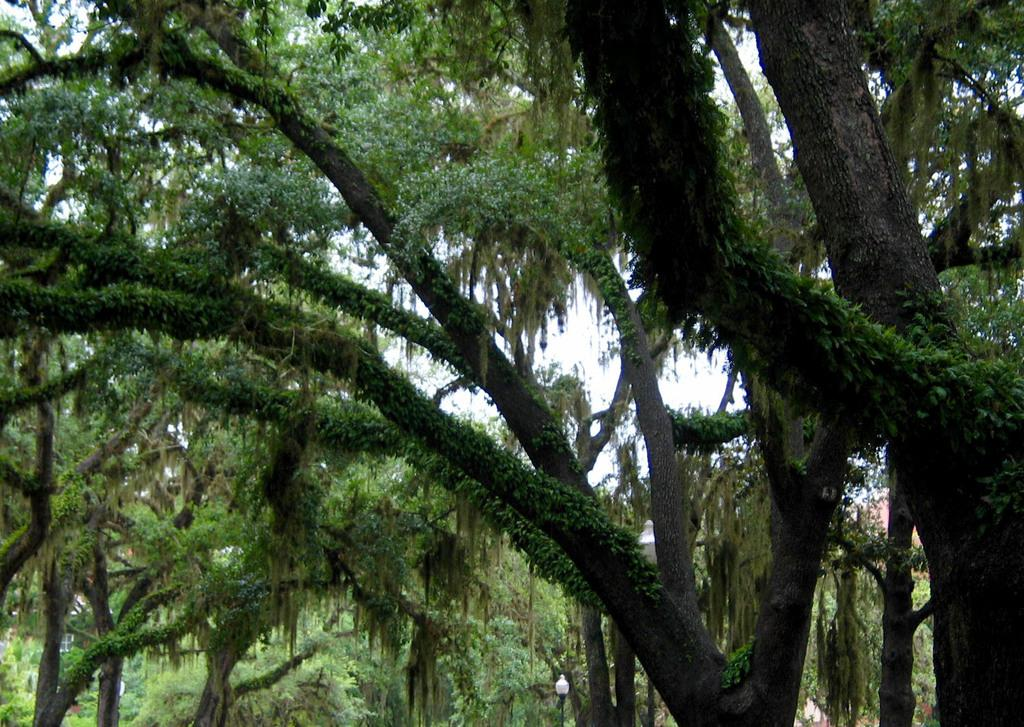What type of trees are present in the image? There are oak trees in the image. What can be observed on the branches of the oak trees? The oak trees have leaves on their branches. What part of the oak trees is visible in the image? The oak trees have visible trunks. How many bananas can be seen hanging from the oak trees in the image? There are no bananas present in the image; the oak trees have leaves on their branches. 